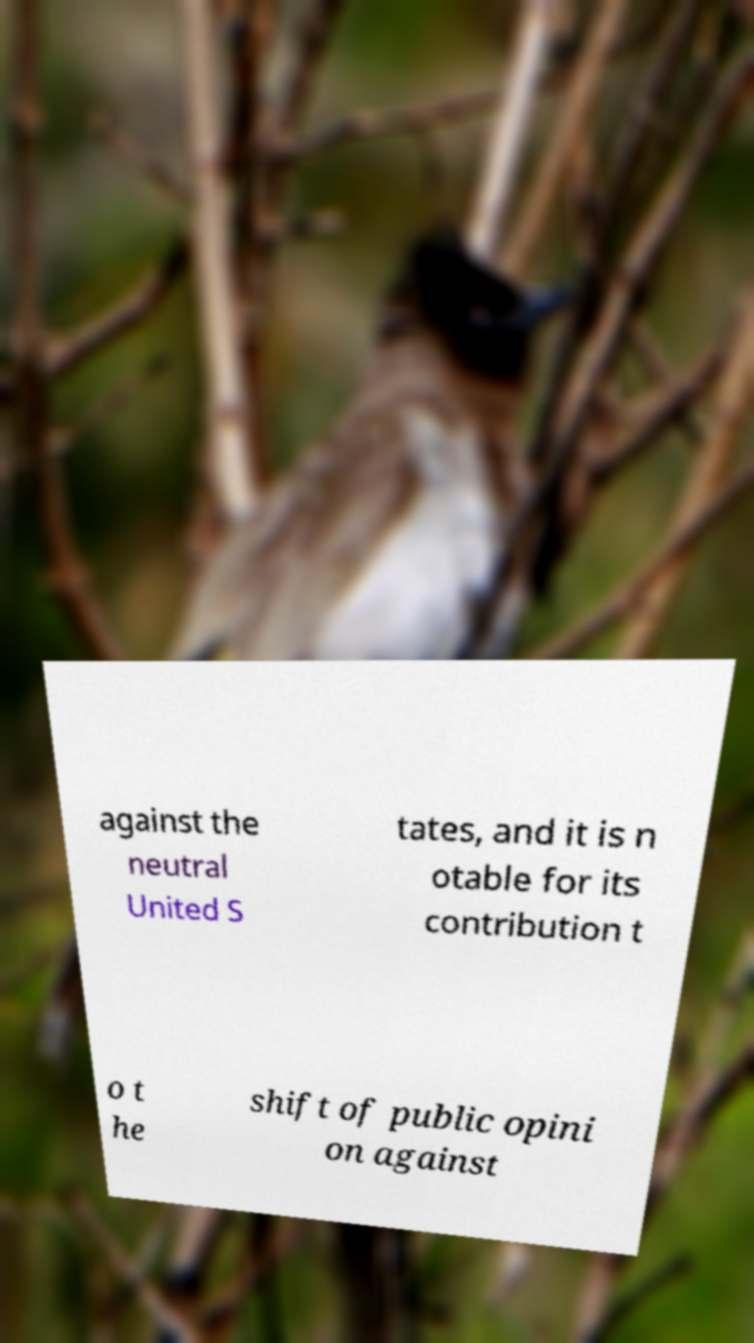Could you assist in decoding the text presented in this image and type it out clearly? against the neutral United S tates, and it is n otable for its contribution t o t he shift of public opini on against 